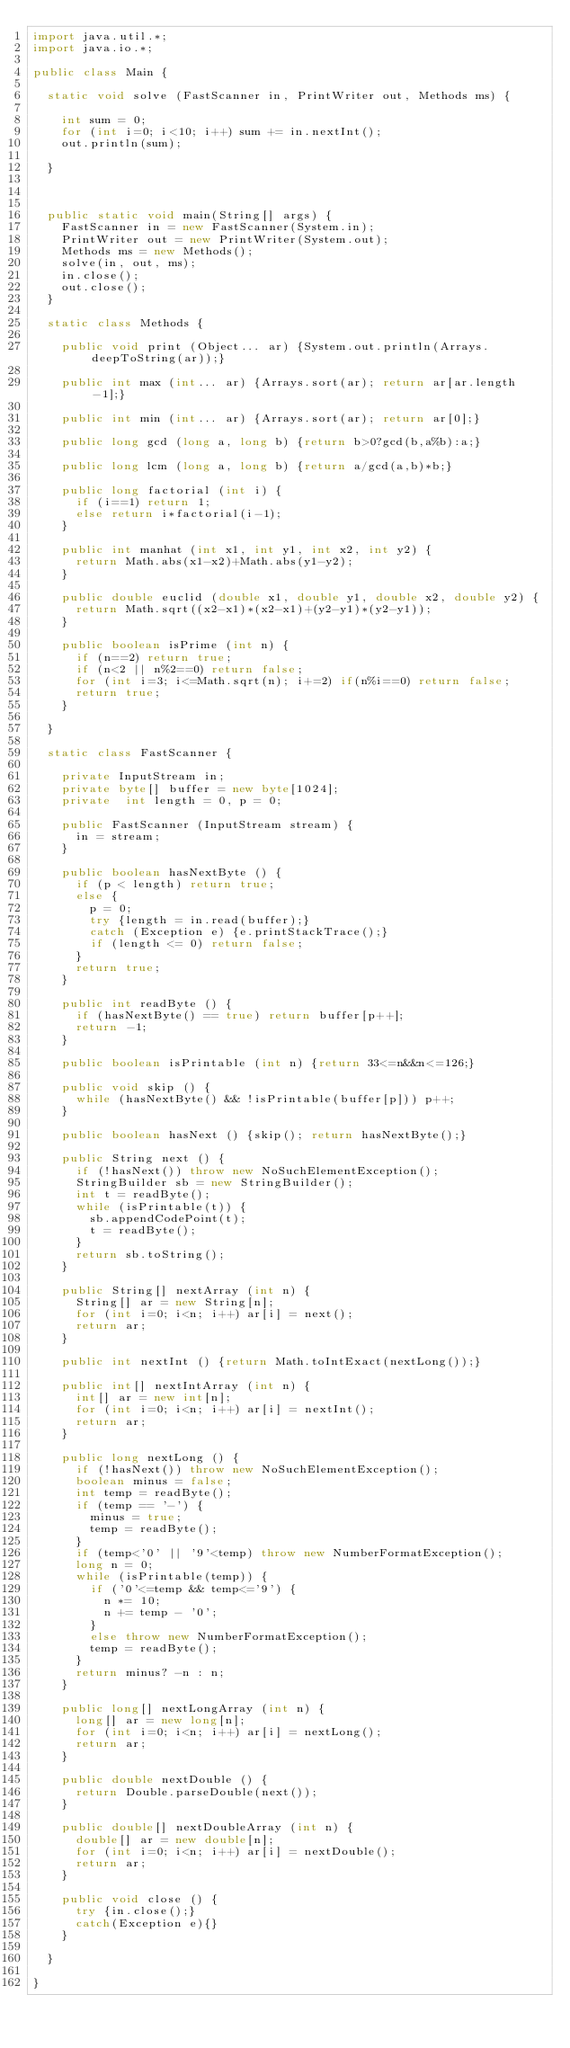<code> <loc_0><loc_0><loc_500><loc_500><_Java_>import java.util.*;
import java.io.*;

public class Main {

	static void solve (FastScanner in, PrintWriter out, Methods ms) {
		
		int sum = 0;
		for (int i=0; i<10; i++) sum += in.nextInt();
		out.println(sum);
		
	}



	public static void main(String[] args) {
		FastScanner in = new FastScanner(System.in);
		PrintWriter out = new PrintWriter(System.out);
		Methods ms = new Methods();
		solve(in, out, ms);
		in.close();
		out.close();
	}

	static class Methods {

		public void print (Object... ar) {System.out.println(Arrays.deepToString(ar));}

		public int max (int... ar) {Arrays.sort(ar); return ar[ar.length-1];}

		public int min (int... ar) {Arrays.sort(ar); return ar[0];}

		public long gcd (long a, long b) {return b>0?gcd(b,a%b):a;}

		public long lcm (long a, long b) {return a/gcd(a,b)*b;}

		public long factorial (int i) {
			if (i==1) return 1;
			else return i*factorial(i-1);
		}

		public int manhat (int x1, int y1, int x2, int y2) {
			return Math.abs(x1-x2)+Math.abs(y1-y2);
		}

		public double euclid (double x1, double y1, double x2, double y2) {
			return Math.sqrt((x2-x1)*(x2-x1)+(y2-y1)*(y2-y1));
		}

		public boolean isPrime (int n) {
			if (n==2) return true;
			if (n<2 || n%2==0) return false;
			for (int i=3; i<=Math.sqrt(n); i+=2) if(n%i==0) return false;
			return true;
		}

	}

	static class FastScanner {

		private InputStream in;
		private byte[] buffer = new byte[1024];
		private  int length = 0, p = 0;

		public FastScanner (InputStream stream) {
			in = stream;
		}

		public boolean hasNextByte () {
			if (p < length) return true;
			else {
				p = 0;
				try {length = in.read(buffer);}
				catch (Exception e) {e.printStackTrace();}
				if (length <= 0) return false;
			}
			return true;
		}

		public int readByte () {
			if (hasNextByte() == true) return buffer[p++];
			return -1;
		}

		public boolean isPrintable (int n) {return 33<=n&&n<=126;}

		public void skip () {
			while (hasNextByte() && !isPrintable(buffer[p])) p++;
		}

		public boolean hasNext () {skip(); return hasNextByte();}

		public String next () {
			if (!hasNext()) throw new NoSuchElementException();
			StringBuilder sb = new StringBuilder();
			int t = readByte();
			while (isPrintable(t)) {
				sb.appendCodePoint(t);
				t = readByte();
			}
			return sb.toString();
		}

		public String[] nextArray (int n) {
			String[] ar = new String[n];
			for (int i=0; i<n; i++) ar[i] = next();
			return ar;
		}

		public int nextInt () {return Math.toIntExact(nextLong());}

		public int[] nextIntArray (int n) {
			int[] ar = new int[n];
			for (int i=0; i<n; i++) ar[i] = nextInt();
			return ar;
		}

		public long nextLong () {
			if (!hasNext()) throw new NoSuchElementException();
			boolean minus = false;
			int temp = readByte();
			if (temp == '-') {
				minus = true;
				temp = readByte();
			}
			if (temp<'0' || '9'<temp) throw new NumberFormatException();
			long n = 0;
			while (isPrintable(temp)) {
				if ('0'<=temp && temp<='9') {
					n *= 10;
					n += temp - '0';
				}
				else throw new NumberFormatException();
				temp = readByte();
			}
			return minus? -n : n;
		}

		public long[] nextLongArray (int n) {
			long[] ar = new long[n];
			for (int i=0; i<n; i++) ar[i] = nextLong();
			return ar;
		}

		public double nextDouble () {
			return Double.parseDouble(next());
		}

		public double[] nextDoubleArray (int n) {
			double[] ar = new double[n];
			for (int i=0; i<n; i++) ar[i] = nextDouble();
			return ar;
		}

		public void close () {
			try {in.close();}
			catch(Exception e){}
		}

	}

}
</code> 